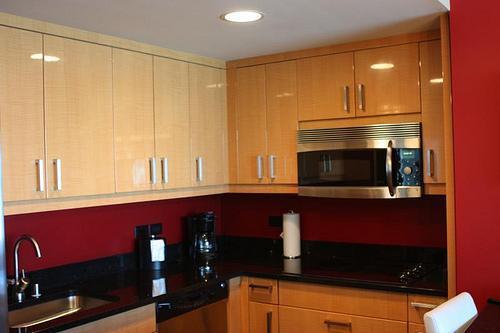How many lights are in the picture?
Give a very brief answer. 1. How many compartments does the sink have?
Give a very brief answer. 1. 